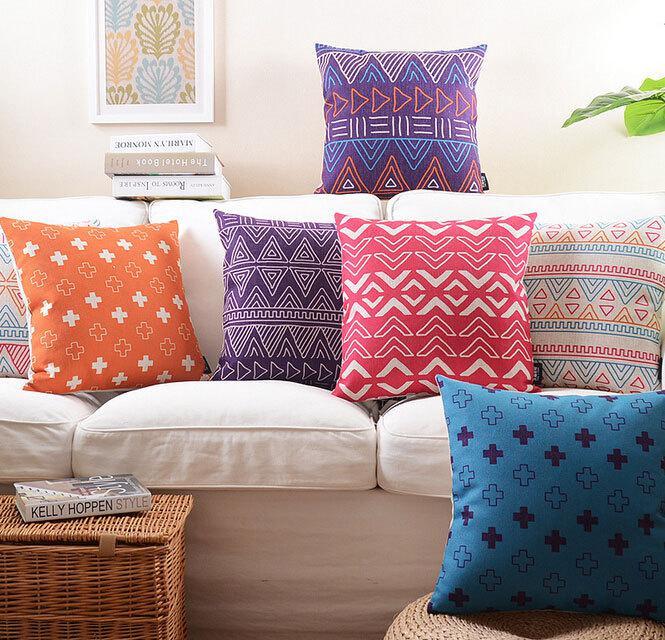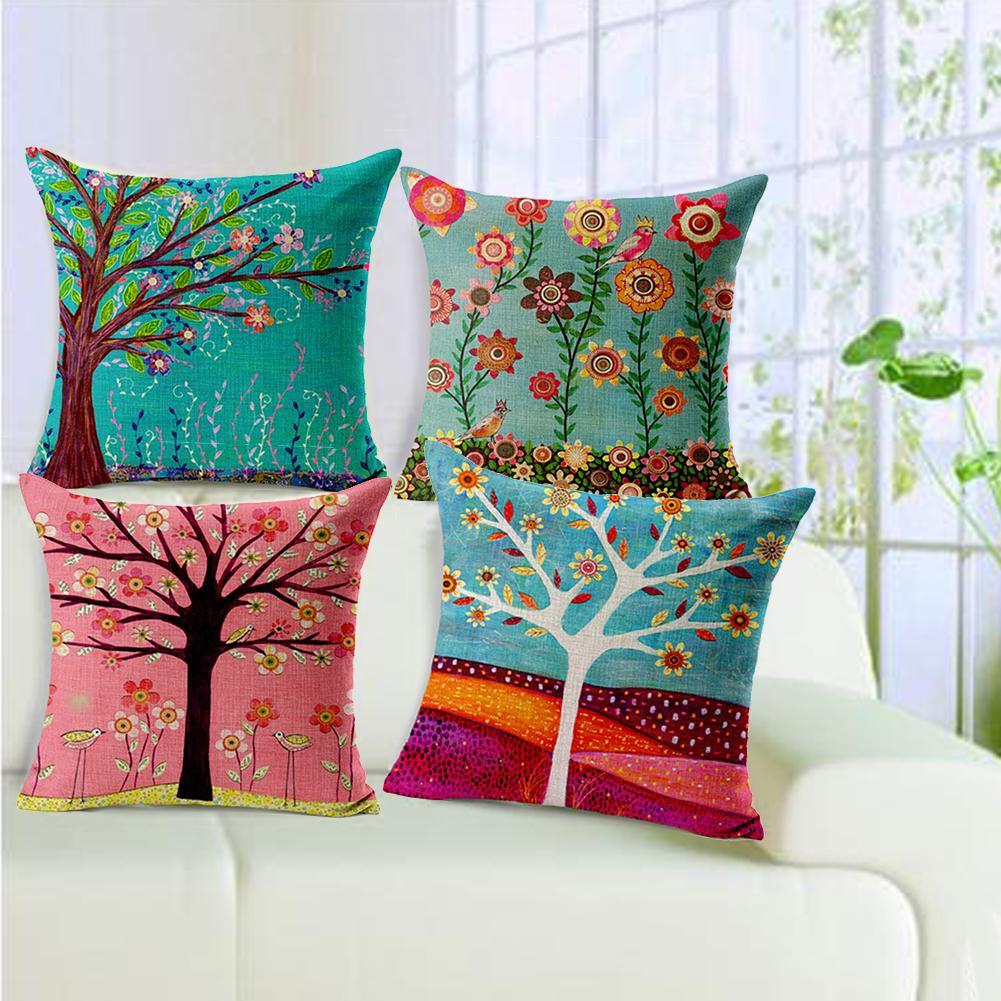The first image is the image on the left, the second image is the image on the right. Given the left and right images, does the statement "At least one piece of fabric has flowers on it." hold true? Answer yes or no. Yes. The first image is the image on the left, the second image is the image on the right. Assess this claim about the two images: "An image shows a neutral-colored couch containing a horizontal row of at least four geometric patterned pillows.". Correct or not? Answer yes or no. Yes. 